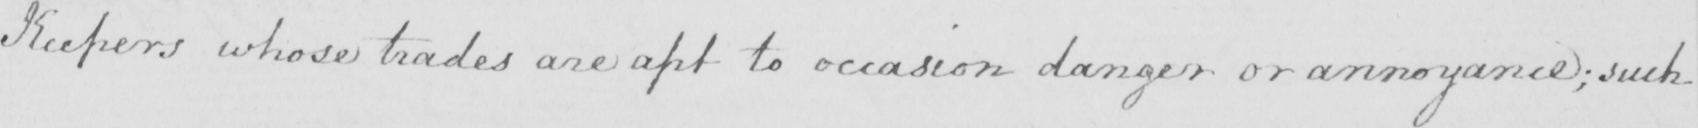What is written in this line of handwriting? Keepers whose trades are apt to occasion danger or annoyance; such 